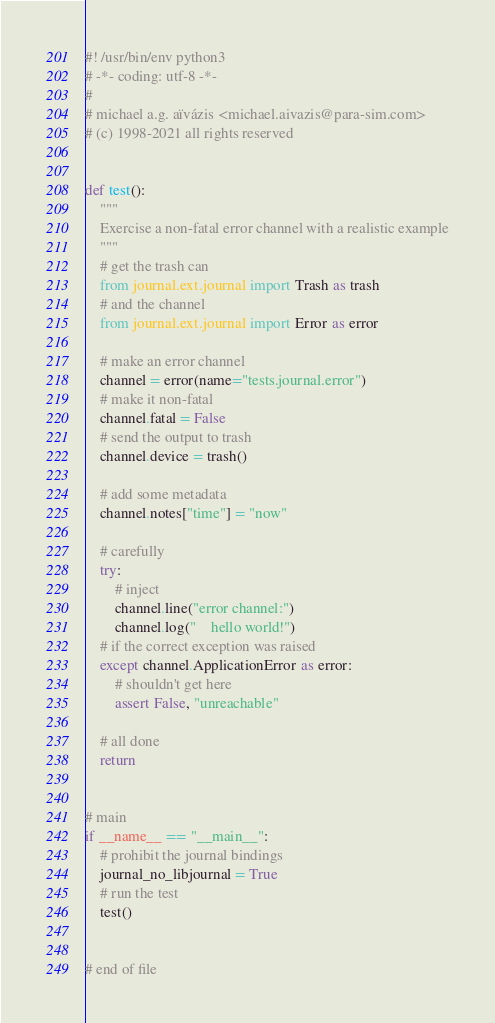Convert code to text. <code><loc_0><loc_0><loc_500><loc_500><_Python_>#! /usr/bin/env python3
# -*- coding: utf-8 -*-
#
# michael a.g. aïvázis <michael.aivazis@para-sim.com>
# (c) 1998-2021 all rights reserved


def test():
    """
    Exercise a non-fatal error channel with a realistic example
    """
    # get the trash can
    from journal.ext.journal import Trash as trash
    # and the channel
    from journal.ext.journal import Error as error

    # make an error channel
    channel = error(name="tests.journal.error")
    # make it non-fatal
    channel.fatal = False
    # send the output to trash
    channel.device = trash()

    # add some metadata
    channel.notes["time"] = "now"

    # carefully
    try:
        # inject
        channel.line("error channel:")
        channel.log("    hello world!")
    # if the correct exception was raised
    except channel.ApplicationError as error:
        # shouldn't get here
        assert False, "unreachable"

    # all done
    return


# main
if __name__ == "__main__":
    # prohibit the journal bindings
    journal_no_libjournal = True
    # run the test
    test()


# end of file
</code> 